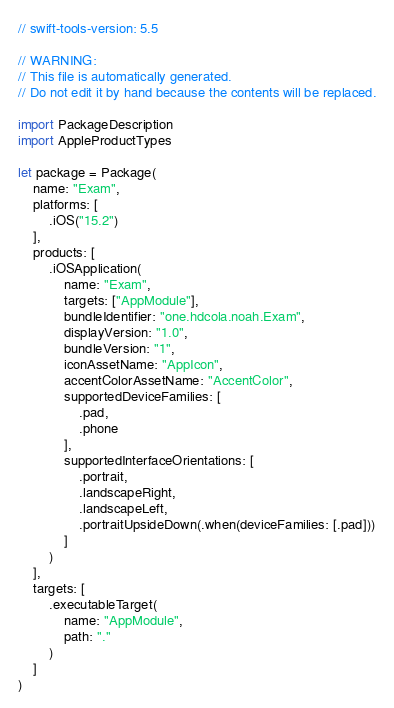<code> <loc_0><loc_0><loc_500><loc_500><_Swift_>// swift-tools-version: 5.5

// WARNING:
// This file is automatically generated.
// Do not edit it by hand because the contents will be replaced.

import PackageDescription
import AppleProductTypes

let package = Package(
    name: "Exam",
    platforms: [
        .iOS("15.2")
    ],
    products: [
        .iOSApplication(
            name: "Exam",
            targets: ["AppModule"],
            bundleIdentifier: "one.hdcola.noah.Exam",
            displayVersion: "1.0",
            bundleVersion: "1",
            iconAssetName: "AppIcon",
            accentColorAssetName: "AccentColor",
            supportedDeviceFamilies: [
                .pad,
                .phone
            ],
            supportedInterfaceOrientations: [
                .portrait,
                .landscapeRight,
                .landscapeLeft,
                .portraitUpsideDown(.when(deviceFamilies: [.pad]))
            ]
        )
    ],
    targets: [
        .executableTarget(
            name: "AppModule",
            path: "."
        )
    ]
)</code> 